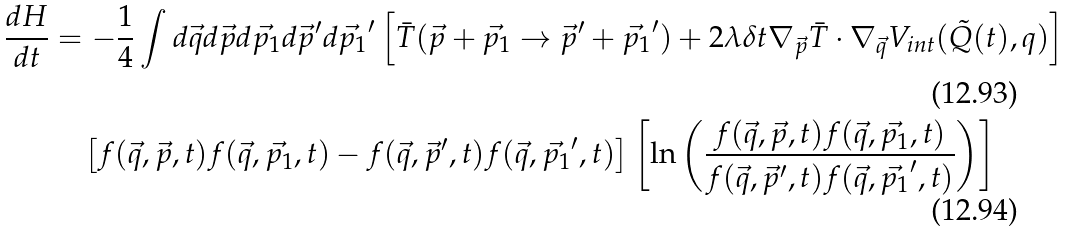Convert formula to latex. <formula><loc_0><loc_0><loc_500><loc_500>\frac { d H } { d t } & = - \frac { 1 } { 4 } \int d \vec { q } d \vec { p } d \vec { p _ { 1 } } d \vec { p } ^ { \prime } d \vec { p _ { 1 } } ^ { \prime } \left [ \bar { T } ( \vec { p } + \vec { p _ { 1 } } \rightarrow \vec { p } ^ { \prime } + \vec { p _ { 1 } } ^ { \prime } ) + 2 \lambda \delta t \nabla _ { \vec { p } } \bar { T } \cdot \nabla _ { \vec { q } } V _ { i n t } ( \tilde { Q } ( t ) , q ) \right ] \\ & \quad \left [ f ( \vec { q } , \vec { p } , t ) f ( \vec { q } , \vec { p _ { 1 } } , t ) - f ( \vec { q } , \vec { p } ^ { \prime } , t ) f ( \vec { q } , \vec { p _ { 1 } } ^ { \prime } , t ) \right ] \left [ \ln \left ( \frac { f ( \vec { q } , \vec { p } , t ) f ( \vec { q } , \vec { p _ { 1 } } , t ) } { f ( \vec { q } , \vec { p } ^ { \prime } , t ) f ( \vec { q } , \vec { p _ { 1 } } ^ { \prime } , t ) } \right ) \right ]</formula> 